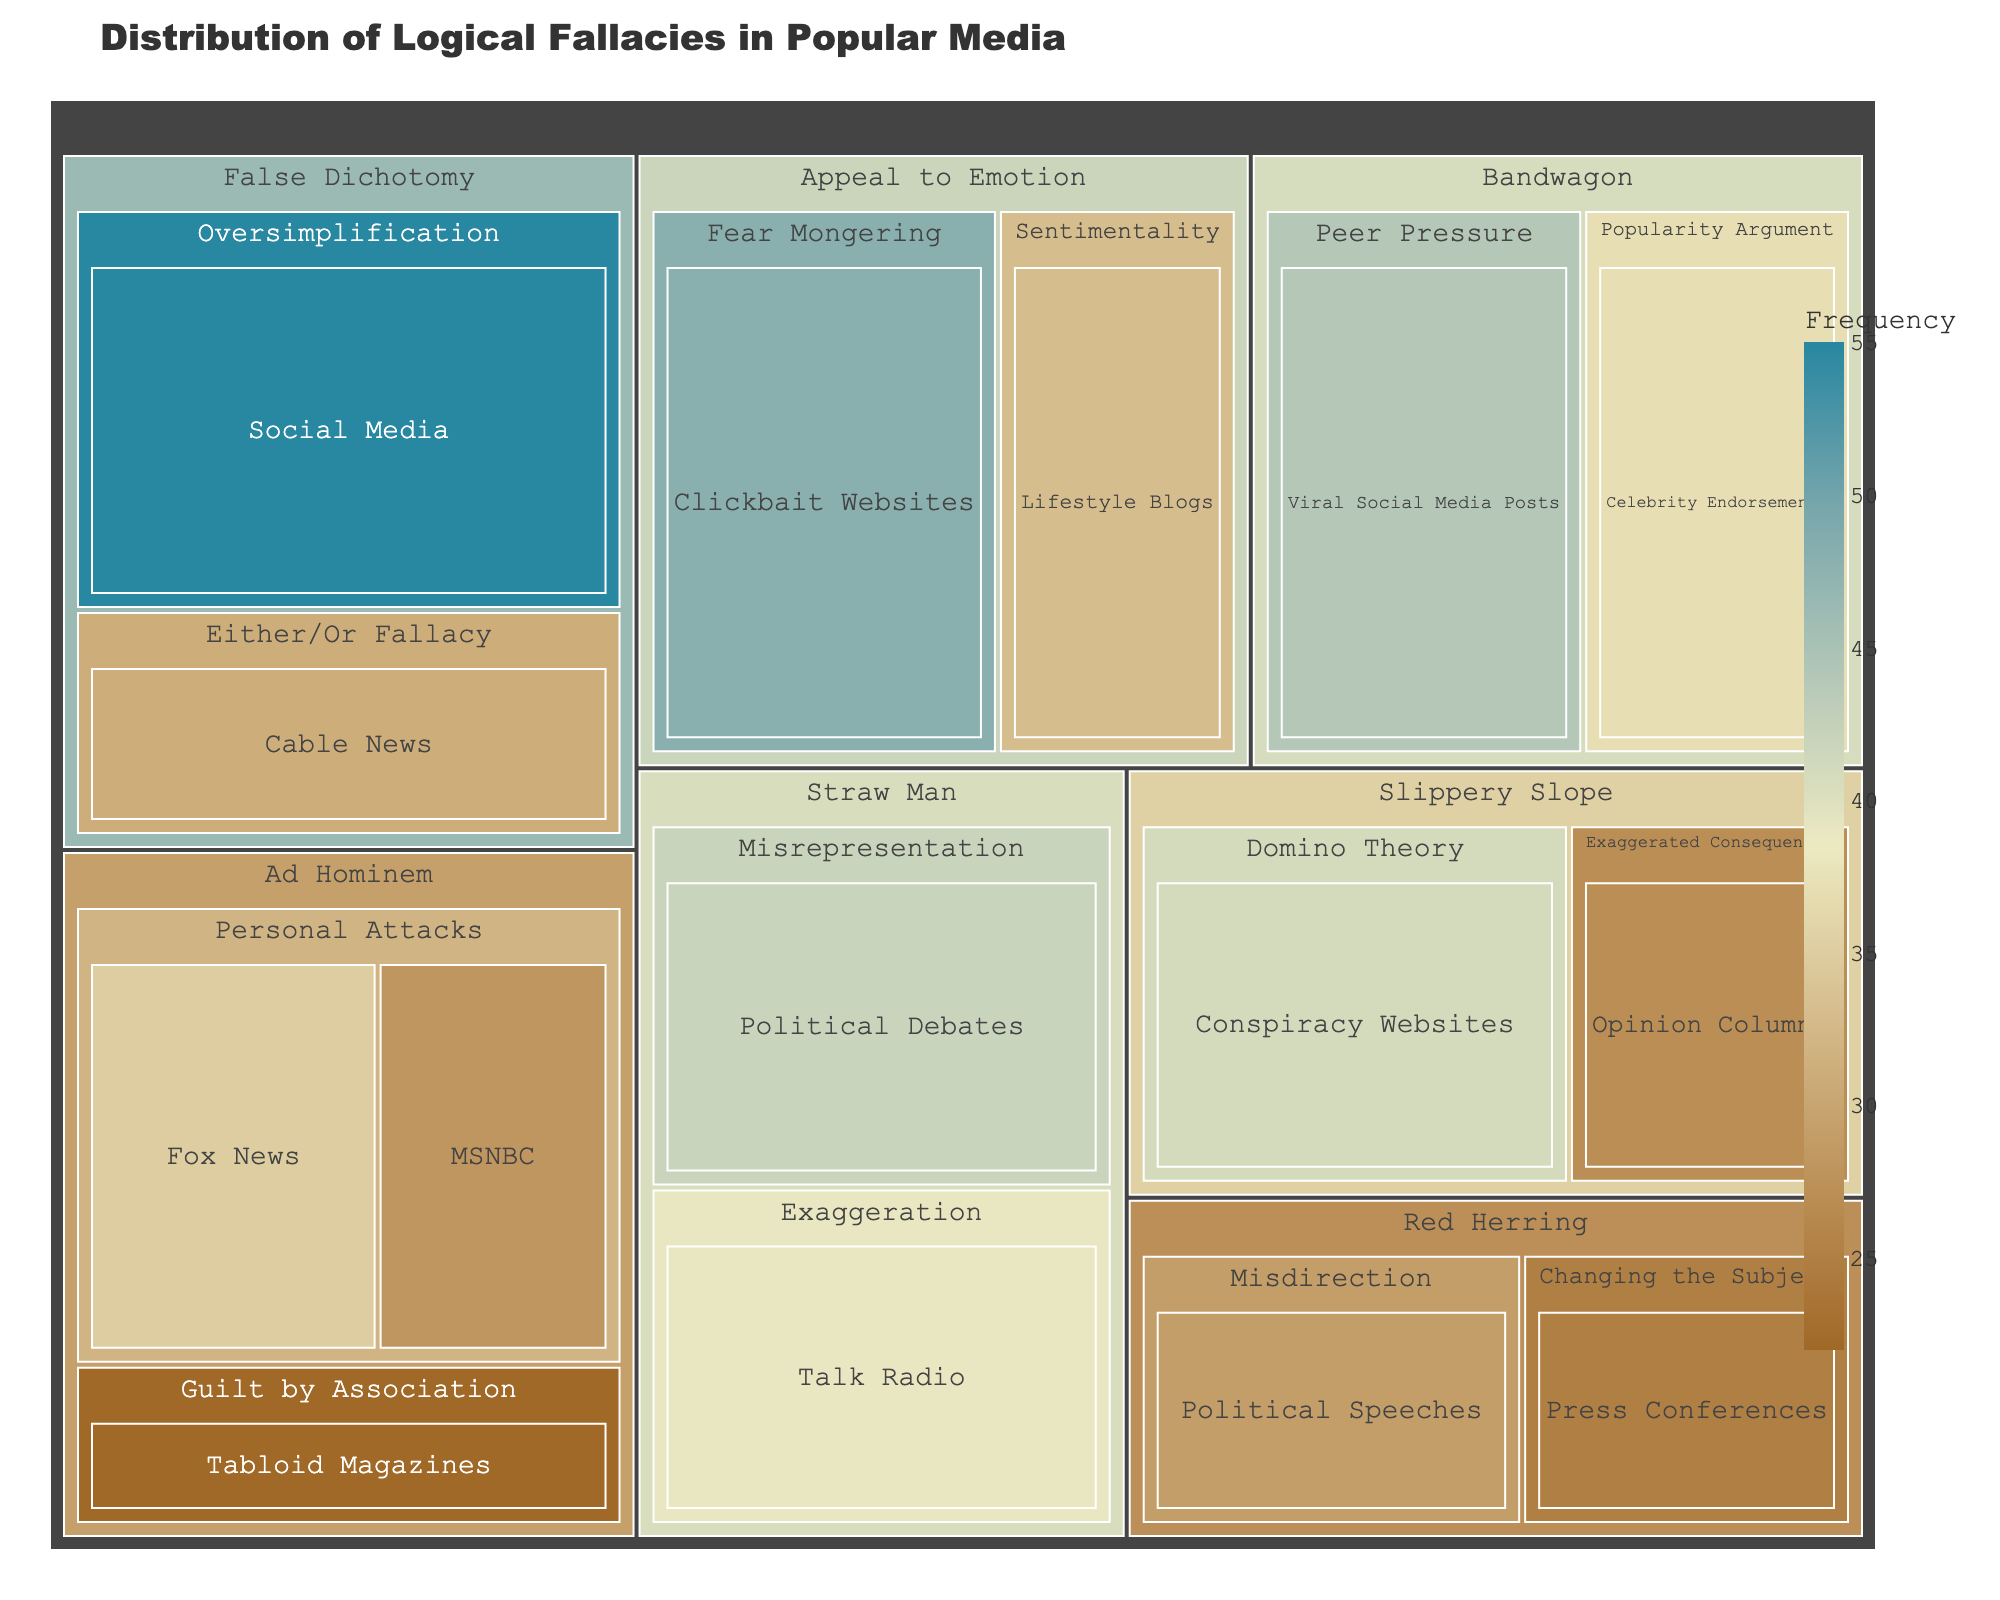what is the title of the plot? The title of the plot is generally the largest text at the top of the figure. It provides an overview of the content.
Answer: Distribution of Logical Fallacies in Popular Media Which source has the highest frequency of False Dichotomy fallacies? To determine the source with the highest frequency of False Dichotomy fallacies, look at the segments under the False Dichotomy category and select the one with the highest value.
Answer: Social Media What is the combined frequency of Ad Hominem fallacies from Fox News and MSNBC? Add the frequencies of Ad Hominem fallacies from Fox News and MSNBC: 35 (Fox News) + 28 (MSNBC).
Answer: 63 Which subcategory under Appeal to Emotion has a higher frequency, Fear Mongering or Sentimentality? Check the values associated with Fear Mongering and Sentimentality under the Appeal to Emotion category. Compare their values (48 vs 33).
Answer: Fear Mongering How does the frequency of Bandwagon fallacies in Viral Social Media Posts compare to those in Celebrity Endorsements? Compare the values of Bandwagon fallacies between Viral Social Media Posts and Celebrity Endorsements by subtracting one from the other: 44 (Viral Social Media Posts) - 37 (Celebrity Endorsements).
Answer: 7 (Viral Social Media Posts is higher by 7) Which has more total fallacies, Red Herring or Slippery Slope? Sum the values of the subcategories under Red Herring and Slippery Slope: Red Herring (29 + 25) = 54; Slippery Slope (27 + 41) = 68. Compare these totals.
Answer: Slippery Slope What are the sources for the subcategories under Straw Man? Identify the sources listed under the Straw Man category in the treemap.
Answer: Political Debates; Talk Radio What is the least frequent fallacy category represented on the treemap? Compare the sum of frequencies of all fallacy categories and identify the one with the smallest total.
Answer: Red Herring What is the frequency difference between the most frequent and least frequent sources? Identify the values of the most frequent source (Social Media with 55) and the least frequent source (Press Conferences with 25) and subtract the latter from the former: 55 - 25.
Answer: 30 Which logical fallacy category is represented by the source "Clickbait Websites"? Identify the category under which the subcategory from the source "Clickbait Websites" falls.
Answer: Appeal to Emotion 